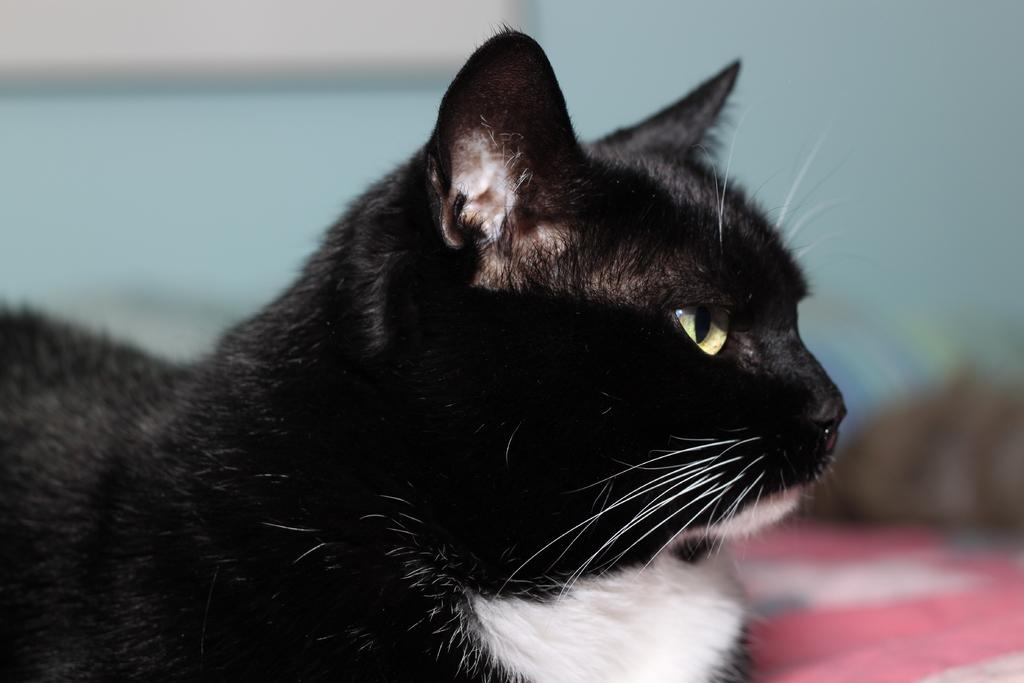What type of animal is in the image? There is a cat in the image. Can you describe the color pattern of the cat? The cat is black and white in color. What can be observed about the background of the image? The background of the image is blurry. How many legs does the cat have in the image? The cat has four legs, but this question is unnecessary as the number of legs is not a relevant detail in the image. 